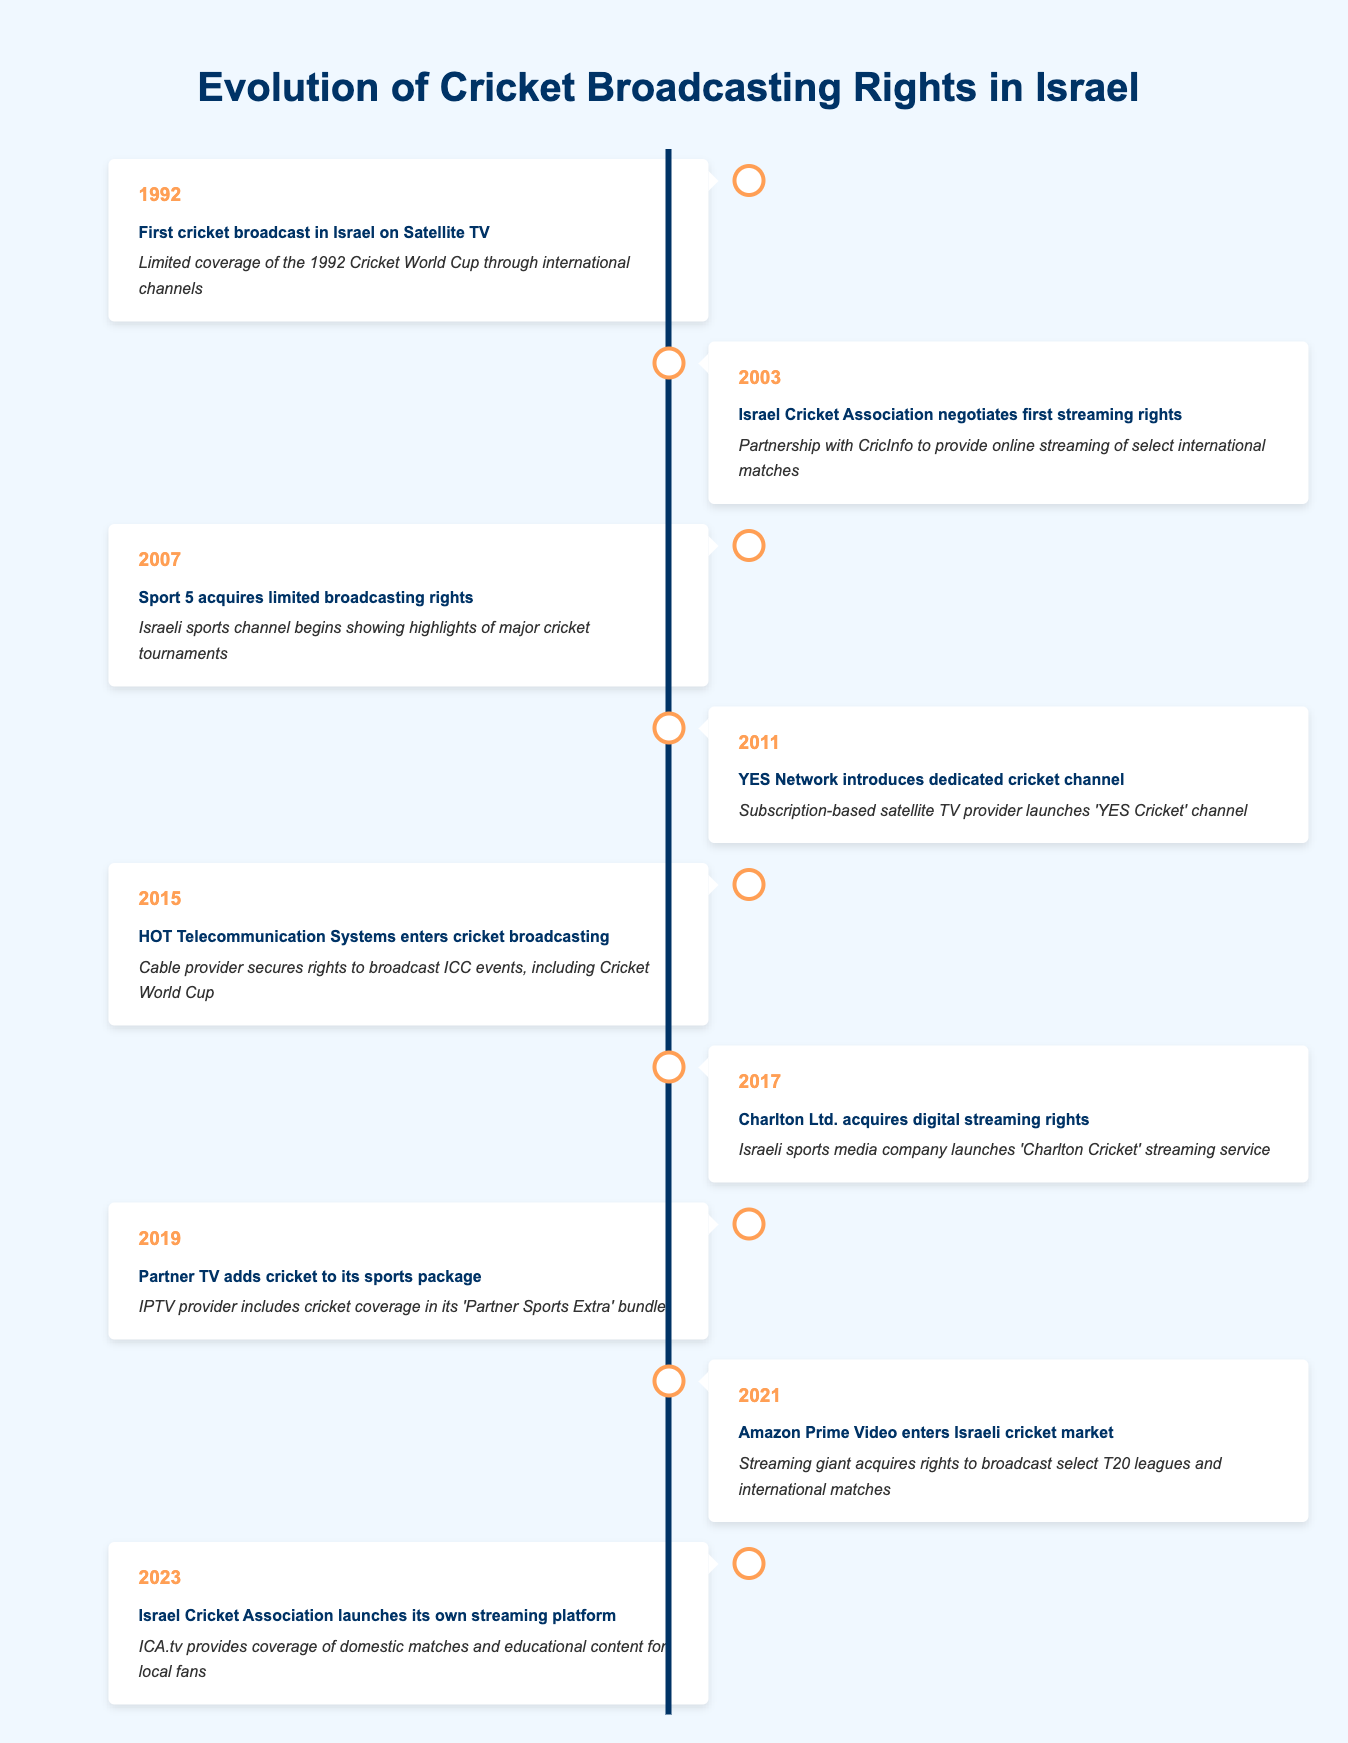What year did the YES Network introduce a dedicated cricket channel? The table indicates that the YES Network launched a dedicated cricket channel in 2011.
Answer: 2011 Which organization negotiated streaming rights for the first time in 2003? The Israel Cricket Association negotiated its first streaming rights in 2003 according to the table.
Answer: Israel Cricket Association How many events were related to the introduction of streaming services? The events related to streaming are in 2003, 2017, and 2021, totaling 3 instances of streaming service introduction.
Answer: 3 Did HOT Telecommunication Systems enter cricket broadcasting before Sport 5? According to the timeline, Sport 5 acquired limited broadcasting rights in 2007, whereas HOT Telecommunication Systems entered cricket broadcasting in 2015, thus HOT entered later than Sport 5.
Answer: Yes What significant step did the Israel Cricket Association take in 2023? In 2023, the Israel Cricket Association launched its own streaming platform, ICA.tv, which is significant as it shows an evolution in broadcasting strategy.
Answer: Launched ICA.tv Which year saw the acquisition of both digital streaming rights and the introduction of a subscription-based cricket channel? The year 2017 saw Charlton Ltd. acquiring digital streaming rights and in 2011, YES Network introduced a dedicated cricket channel. Since they are in different years, there is no single year for both events.
Answer: No single year Count the number of years between the first cricket broadcast and the introduction of Amazon Prime Video in Israel. The first cricket broadcast occurred in 1992, and Amazon Prime Video entered the market in 2021. The difference is 2021 - 1992 = 29 years.
Answer: 29 years What is the most recent development in cricket broadcasting rights in Israel? The most recent development in 2023 is the launch of the ICA.tv platform by the Israel Cricket Association to provide coverage of domestic matches and educational content.
Answer: Launch of ICA.tv 